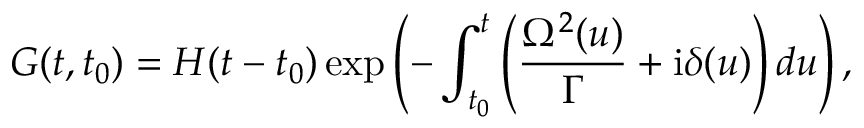Convert formula to latex. <formula><loc_0><loc_0><loc_500><loc_500>G ( t , t _ { 0 } ) = H ( t - t _ { 0 } ) \exp \left ( - \int _ { t _ { 0 } } ^ { t } \left ( \frac { \Omega ^ { 2 } ( u ) } { \Gamma } + i \delta ( u ) \right ) d u \right ) ,</formula> 